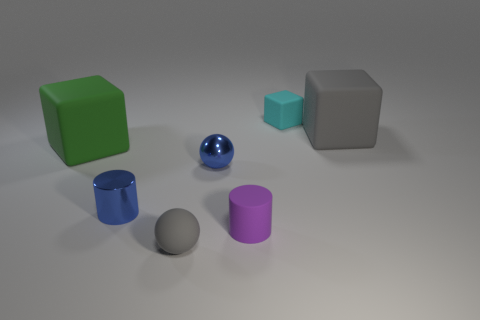Which objects in the image appear to have a reflective surface? The blue sphere and the cylinder both have reflective surfaces, evident by the light highlights and the clarity of the reflections on them.  Are there any objects that seem out of place in this arrangement? All the objects seem deliberately placed with no clear incongruity, though the smallest cube may appear slightly out of scale with the rest. 